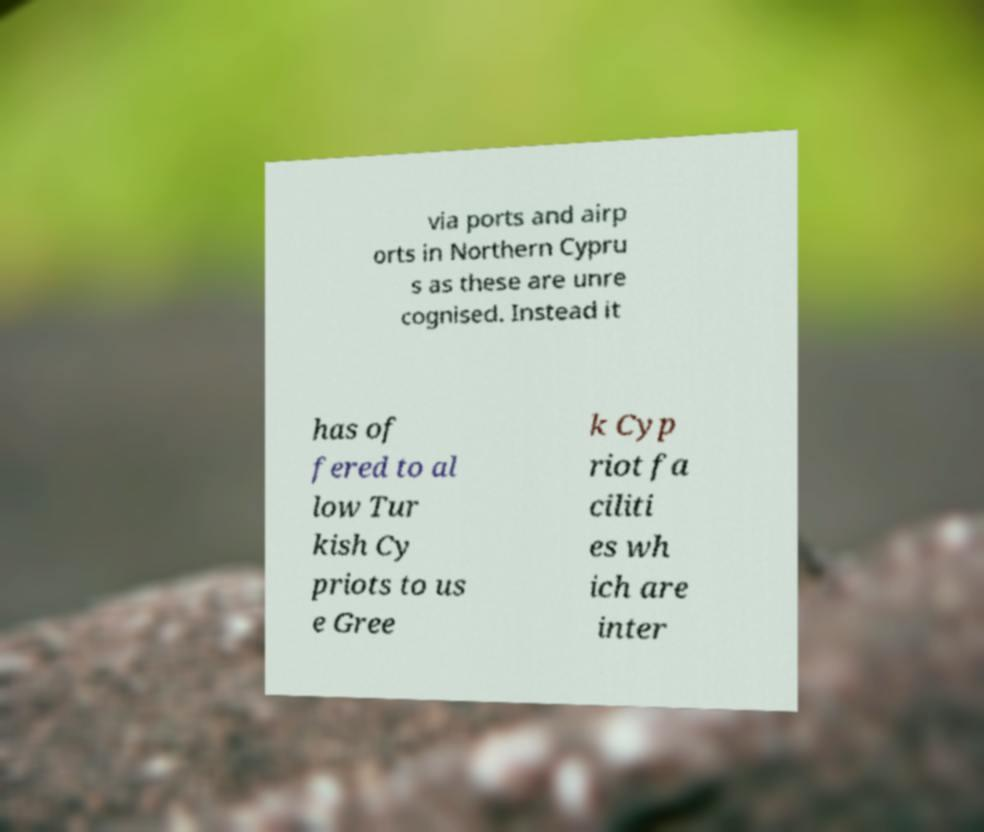Could you assist in decoding the text presented in this image and type it out clearly? via ports and airp orts in Northern Cypru s as these are unre cognised. Instead it has of fered to al low Tur kish Cy priots to us e Gree k Cyp riot fa ciliti es wh ich are inter 